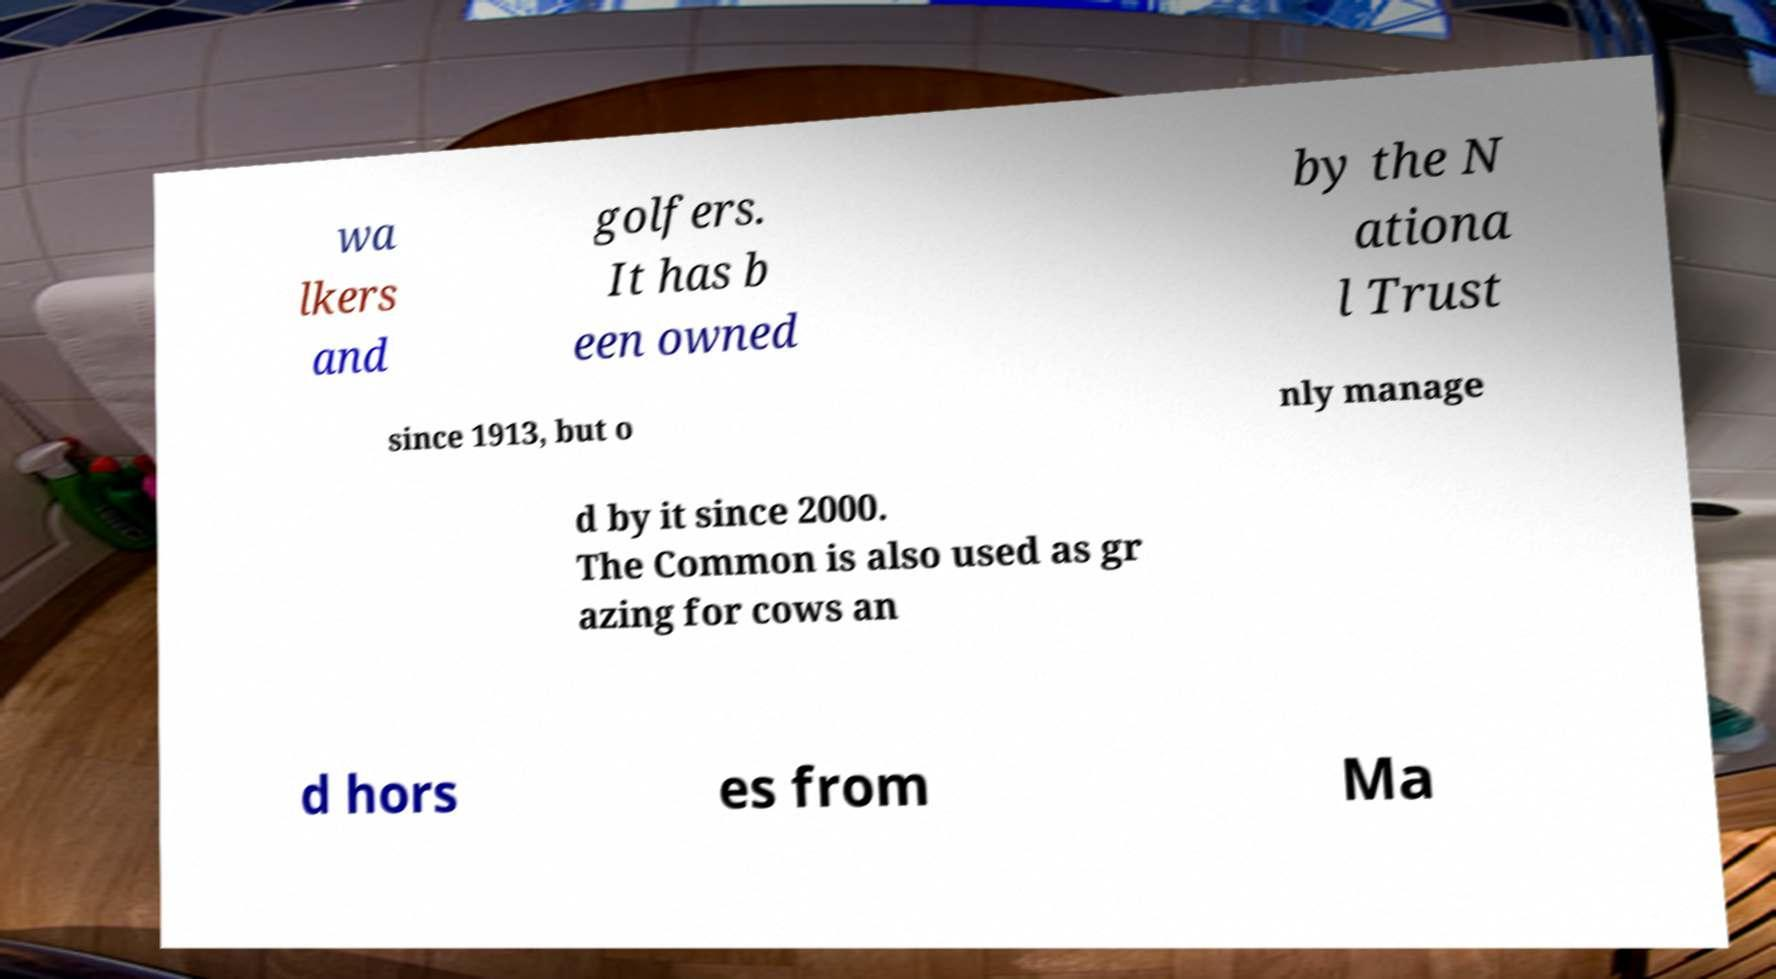Can you accurately transcribe the text from the provided image for me? wa lkers and golfers. It has b een owned by the N ationa l Trust since 1913, but o nly manage d by it since 2000. The Common is also used as gr azing for cows an d hors es from Ma 